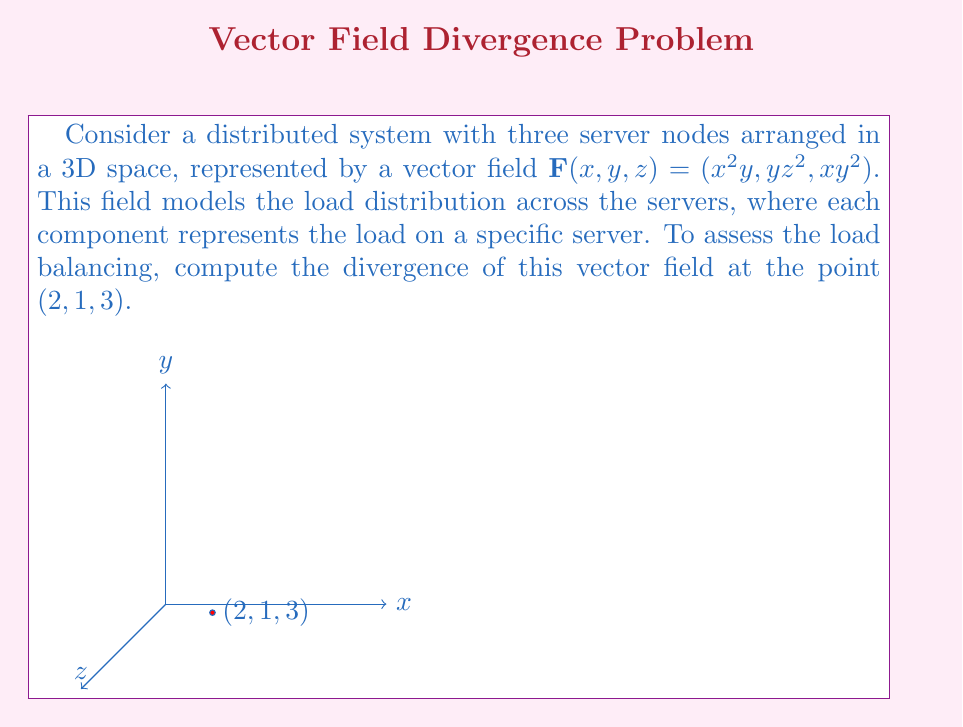What is the answer to this math problem? To compute the divergence of the vector field $\mathbf{F}(x, y, z) = (x^2y, yz^2, xy^2)$, we need to follow these steps:

1) The divergence of a vector field $\mathbf{F}(x, y, z) = (F_1, F_2, F_3)$ is given by:

   $$\text{div}\mathbf{F} = \nabla \cdot \mathbf{F} = \frac{\partial F_1}{\partial x} + \frac{\partial F_2}{\partial y} + \frac{\partial F_3}{\partial z}$$

2) For our vector field:
   $F_1 = x^2y$
   $F_2 = yz^2$
   $F_3 = xy^2$

3) Let's compute each partial derivative:

   $\frac{\partial F_1}{\partial x} = \frac{\partial}{\partial x}(x^2y) = 2xy$

   $\frac{\partial F_2}{\partial y} = \frac{\partial}{\partial y}(yz^2) = z^2$

   $\frac{\partial F_3}{\partial z} = \frac{\partial}{\partial z}(xy^2) = 0$

4) Now, we can sum these partial derivatives:

   $$\text{div}\mathbf{F} = 2xy + z^2 + 0 = 2xy + z^2$$

5) Finally, we evaluate this at the point $(2, 1, 3)$:

   $$\text{div}\mathbf{F}(2, 1, 3) = 2(2)(1) + 3^2 = 4 + 9 = 13$$

This positive divergence indicates that there's a net outflow of load from the point $(2, 1, 3)$, suggesting potential load imbalance among the servers.
Answer: 13 